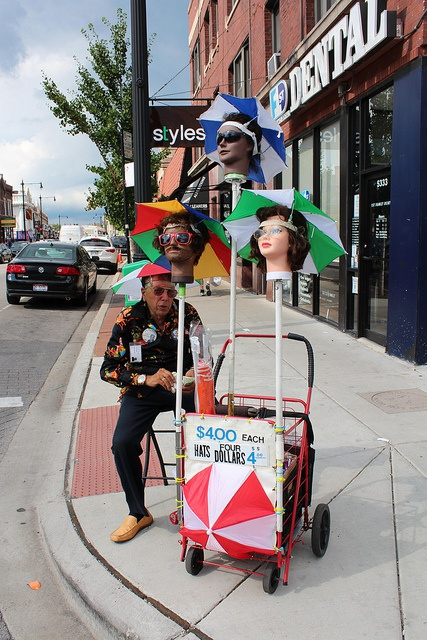Describe the objects in this image and their specific colors. I can see people in lightblue, black, maroon, darkgray, and lightgray tones, umbrella in darkgray, lavender, salmon, pink, and red tones, car in darkgray, black, and gray tones, umbrella in darkgray, green, and lavender tones, and umbrella in darkgray, brown, green, maroon, and orange tones in this image. 